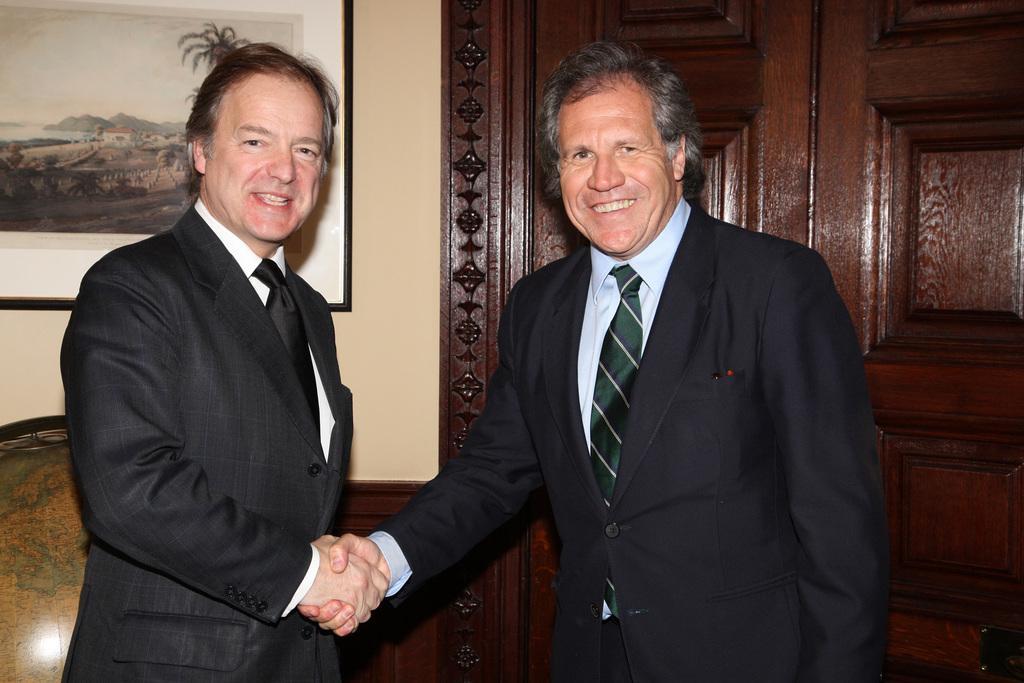Describe this image in one or two sentences. In this image in the foreground there are two persons smiling, and they are shaking hand with each other. And in the background there is a door, photo frame, globe and wall. 